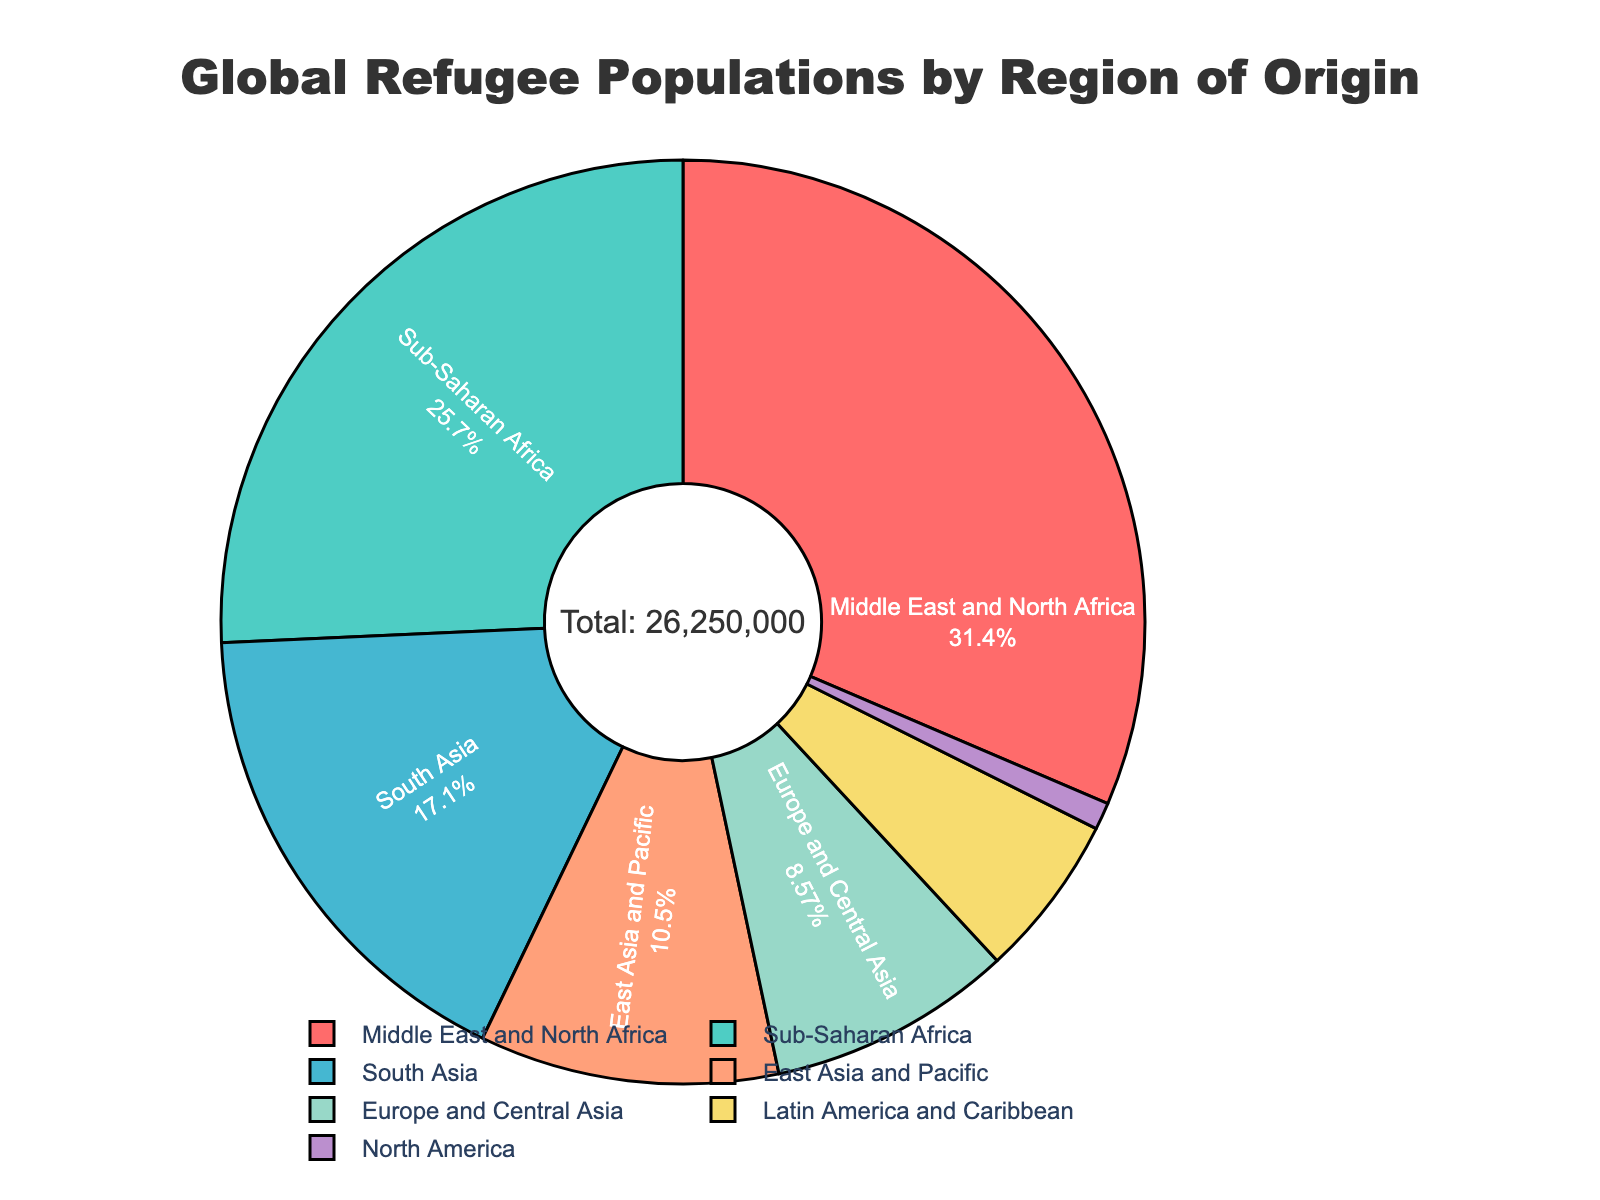What percentage of the global refugee population originates from the Middle East and North Africa? The pie chart includes labels with percentages for each region. The Middle East and North Africa segment shows the specific percentage of the total refugee population from that region.
Answer: 37.0% Which region has the smallest refugee population, and what is the number? By observing the smallest segment of the pie chart, we see that North America has the smallest refugee population. The hover info indicates that this number is 250,000.
Answer: North America, 250,000 How many more refugees originate from Sub-Saharan Africa compared to Latin America and the Caribbean? By identifying the segments for Sub-Saharan Africa (6,750,000 refugees) and Latin America and the Caribbean (1,500,000 refugees), and subtracting the latter from the former, we calculate 6,750,000 - 1,500,000 = 5,250,000.
Answer: 5,250,000 What is the total number of refugees originating from regions other than the Middle East and North Africa? The total number of refugees (24,000,000) can be calculated by summing all regional figures. Subtract Middle East and North Africa (8,250,000) from the total: 24,000,000 - 8,250,000 = 15,750,000.
Answer: 15,750,000 Which region constitutes around one-third (33.3%) of the global refugee population? Observing the pie chart's percentages, the Middle East and North Africa is the closest to one-third of the total refugee population with 37.0%.
Answer: Middle East and North Africa How does the number of South Asian refugees compare to East Asian and Pacific refugees? By examining their respective segments on the pie chart, South Asia has 4,500,000 refugees; East Asia and Pacific has 2,750,000. Comparing indicates South Asia has a higher number.
Answer: South Asia has more If the number of refugees from Europe and Central Asia doubled, how would it compare to the current number from Sub-Saharan Africa? Europe and Central Asia currently has 2,250,000 refugees. Doubling this number would result in 4,500,000. Sub-Saharan Africa has 6,750,000 refugees. The doubled figure from Europe and Central Asia is still less than Sub-Saharan Africa.
Answer: It would still be less What is the sum of refugees originating from both the Americas (North America, Latin America, and Caribbean)? Adding the figures: North America (250,000) and Latin America and Caribbean (1,500,000) results in 1,750,000.
Answer: 1,750,000 